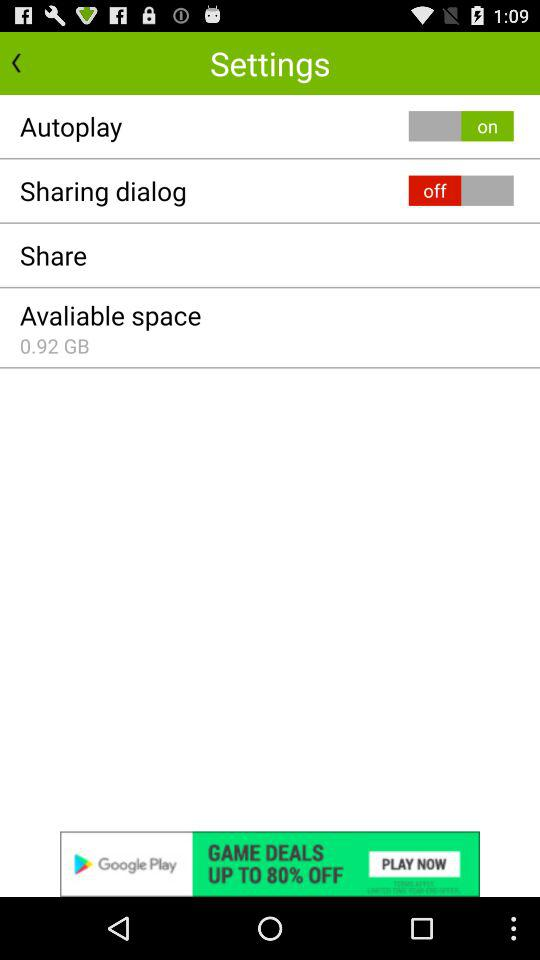With which applications can this be shared?
When the provided information is insufficient, respond with <no answer>. <no answer> 